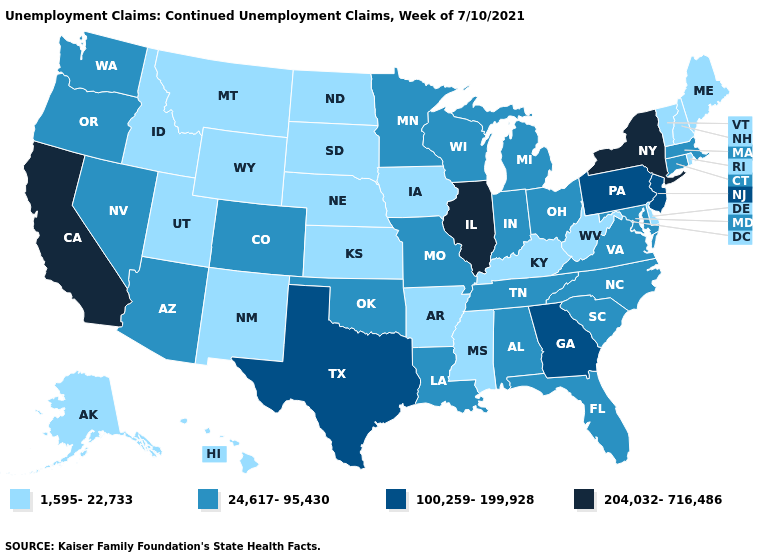Name the states that have a value in the range 24,617-95,430?
Quick response, please. Alabama, Arizona, Colorado, Connecticut, Florida, Indiana, Louisiana, Maryland, Massachusetts, Michigan, Minnesota, Missouri, Nevada, North Carolina, Ohio, Oklahoma, Oregon, South Carolina, Tennessee, Virginia, Washington, Wisconsin. Does Montana have a lower value than Texas?
Concise answer only. Yes. Name the states that have a value in the range 204,032-716,486?
Concise answer only. California, Illinois, New York. Does Delaware have the highest value in the USA?
Give a very brief answer. No. What is the value of New Mexico?
Write a very short answer. 1,595-22,733. Among the states that border New Mexico , which have the highest value?
Quick response, please. Texas. What is the highest value in the USA?
Answer briefly. 204,032-716,486. Does North Carolina have the lowest value in the South?
Concise answer only. No. Which states have the lowest value in the West?
Keep it brief. Alaska, Hawaii, Idaho, Montana, New Mexico, Utah, Wyoming. Does the first symbol in the legend represent the smallest category?
Keep it brief. Yes. What is the lowest value in the South?
Short answer required. 1,595-22,733. Name the states that have a value in the range 1,595-22,733?
Be succinct. Alaska, Arkansas, Delaware, Hawaii, Idaho, Iowa, Kansas, Kentucky, Maine, Mississippi, Montana, Nebraska, New Hampshire, New Mexico, North Dakota, Rhode Island, South Dakota, Utah, Vermont, West Virginia, Wyoming. Name the states that have a value in the range 100,259-199,928?
Answer briefly. Georgia, New Jersey, Pennsylvania, Texas. Name the states that have a value in the range 1,595-22,733?
Quick response, please. Alaska, Arkansas, Delaware, Hawaii, Idaho, Iowa, Kansas, Kentucky, Maine, Mississippi, Montana, Nebraska, New Hampshire, New Mexico, North Dakota, Rhode Island, South Dakota, Utah, Vermont, West Virginia, Wyoming. Name the states that have a value in the range 1,595-22,733?
Answer briefly. Alaska, Arkansas, Delaware, Hawaii, Idaho, Iowa, Kansas, Kentucky, Maine, Mississippi, Montana, Nebraska, New Hampshire, New Mexico, North Dakota, Rhode Island, South Dakota, Utah, Vermont, West Virginia, Wyoming. 